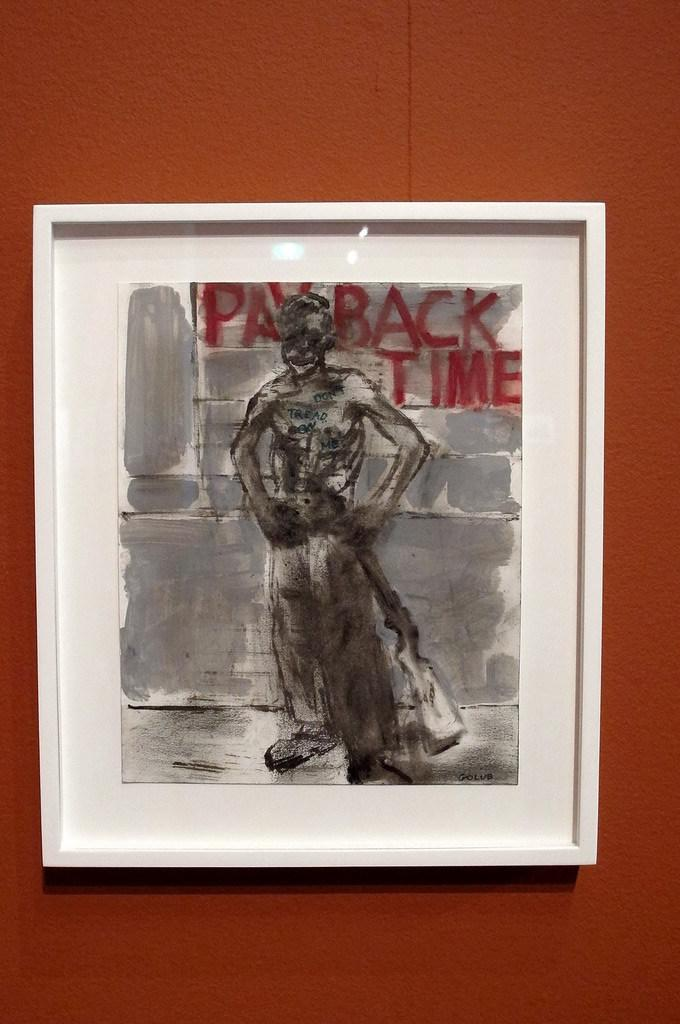Provide a one-sentence caption for the provided image. A slender man standing with his hands on his hips in front of a grey brick wall in front of the words in red, "payback time.'. 